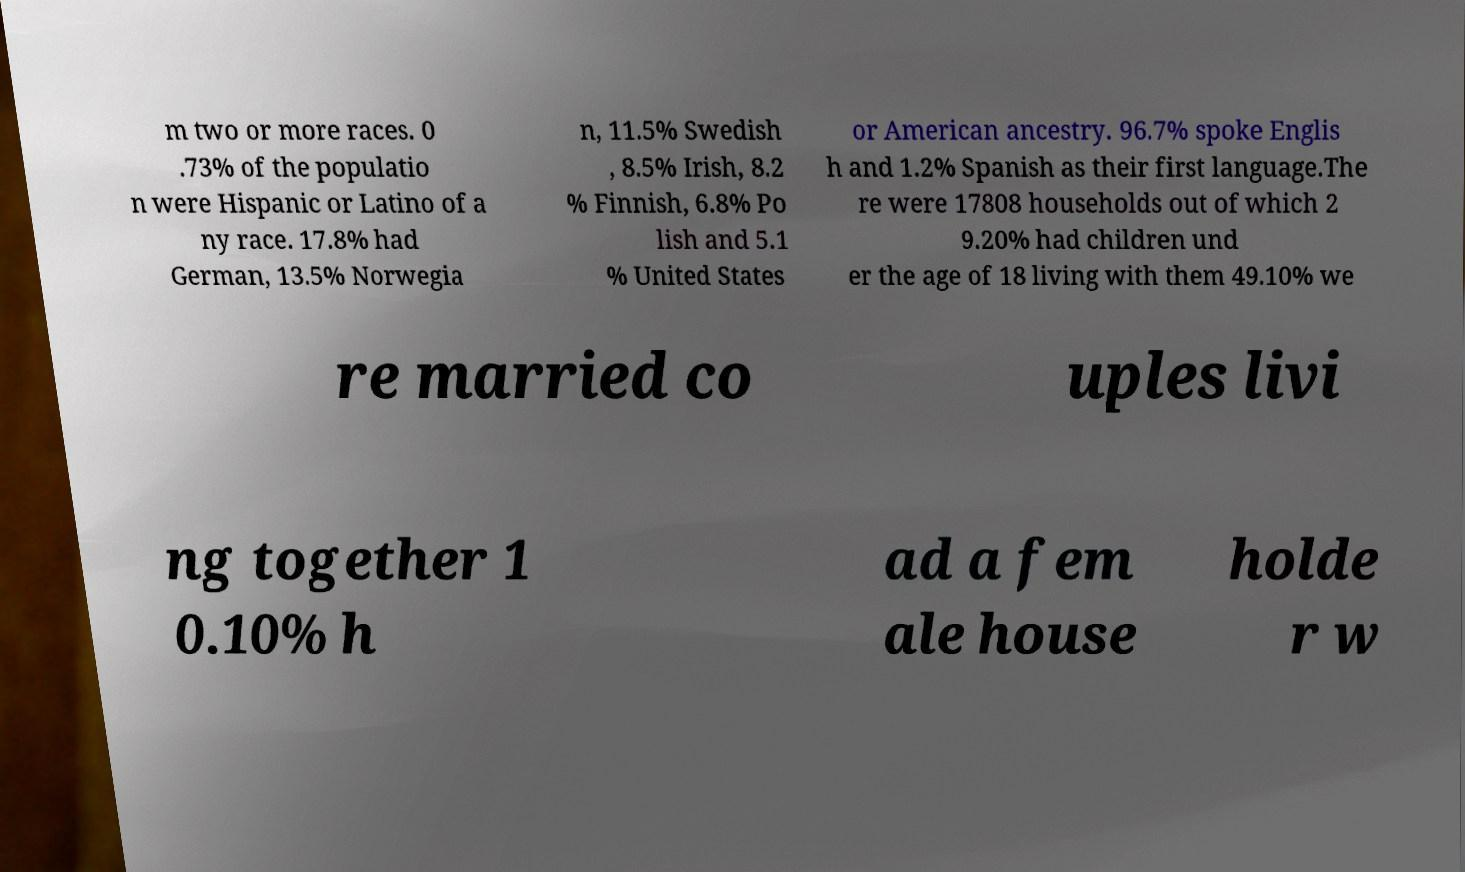For documentation purposes, I need the text within this image transcribed. Could you provide that? m two or more races. 0 .73% of the populatio n were Hispanic or Latino of a ny race. 17.8% had German, 13.5% Norwegia n, 11.5% Swedish , 8.5% Irish, 8.2 % Finnish, 6.8% Po lish and 5.1 % United States or American ancestry. 96.7% spoke Englis h and 1.2% Spanish as their first language.The re were 17808 households out of which 2 9.20% had children und er the age of 18 living with them 49.10% we re married co uples livi ng together 1 0.10% h ad a fem ale house holde r w 